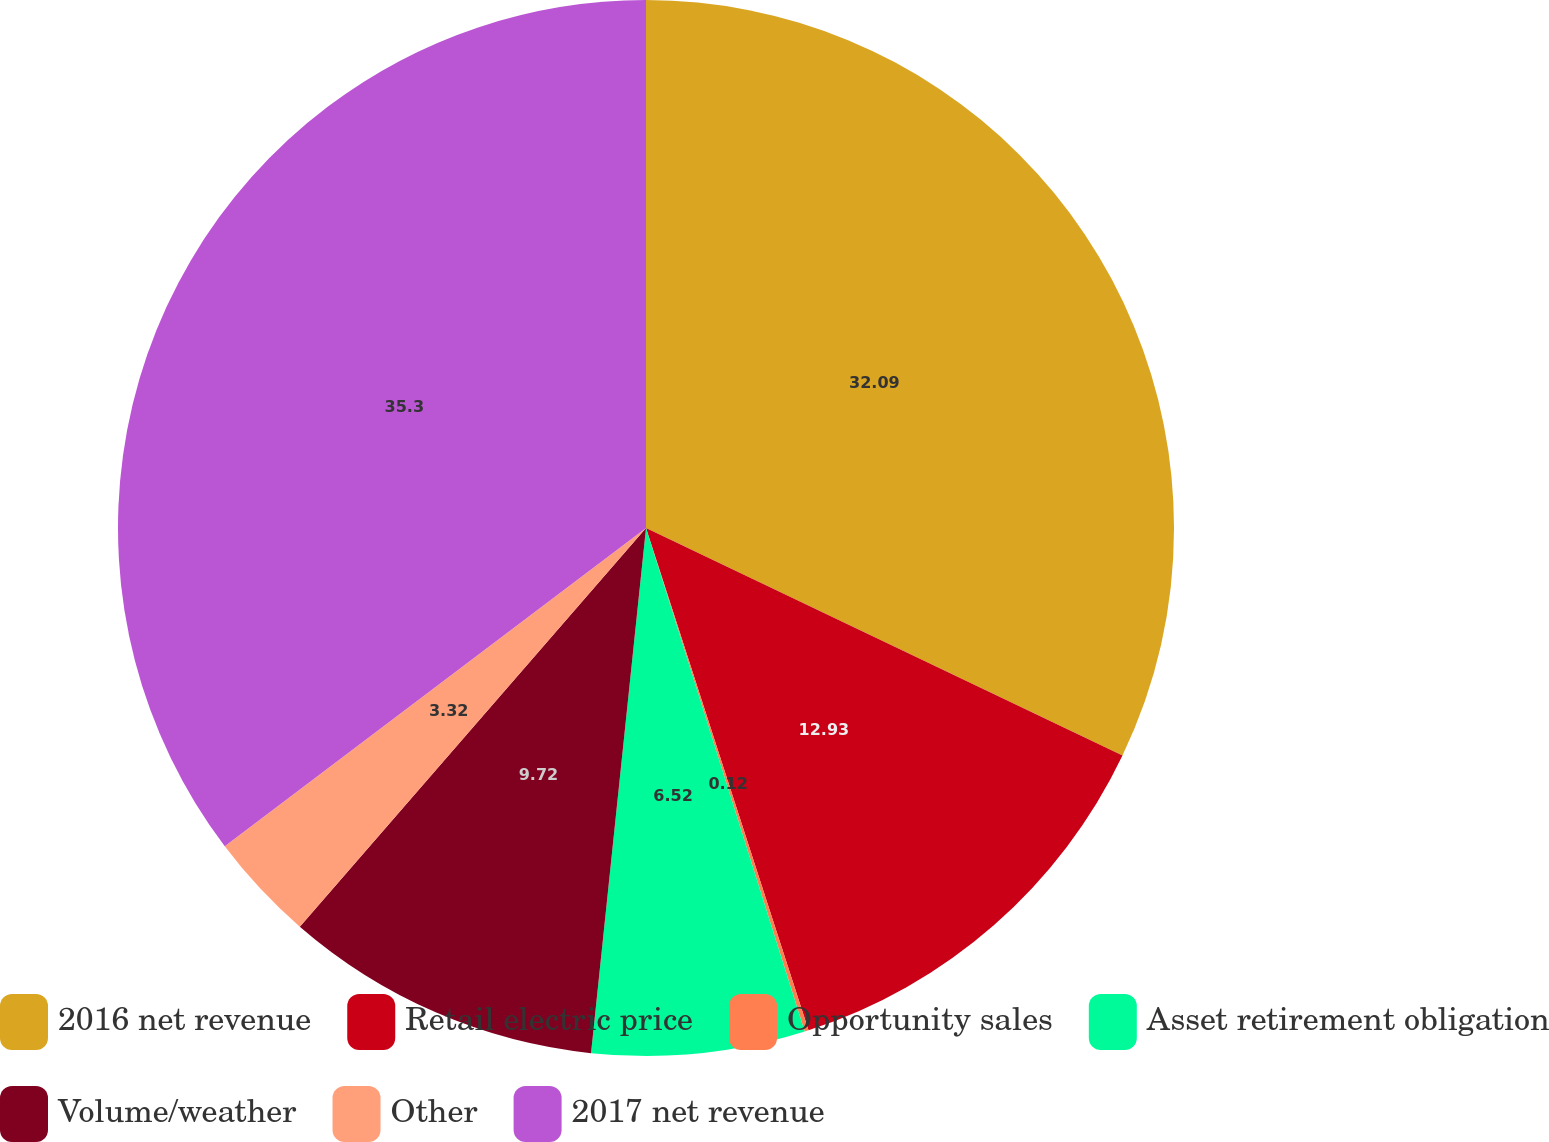<chart> <loc_0><loc_0><loc_500><loc_500><pie_chart><fcel>2016 net revenue<fcel>Retail electric price<fcel>Opportunity sales<fcel>Asset retirement obligation<fcel>Volume/weather<fcel>Other<fcel>2017 net revenue<nl><fcel>32.09%<fcel>12.93%<fcel>0.12%<fcel>6.52%<fcel>9.72%<fcel>3.32%<fcel>35.3%<nl></chart> 